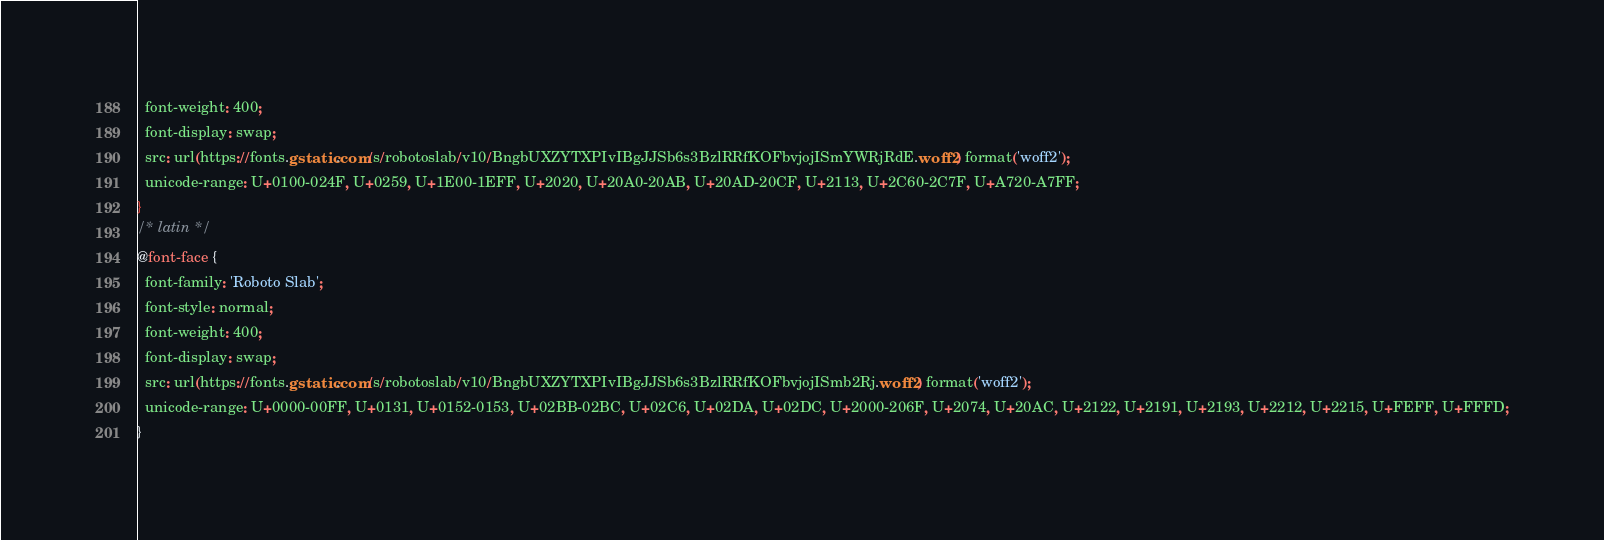Convert code to text. <code><loc_0><loc_0><loc_500><loc_500><_CSS_>  font-weight: 400;
  font-display: swap;
  src: url(https://fonts.gstatic.com/s/robotoslab/v10/BngbUXZYTXPIvIBgJJSb6s3BzlRRfKOFbvjojISmYWRjRdE.woff2) format('woff2');
  unicode-range: U+0100-024F, U+0259, U+1E00-1EFF, U+2020, U+20A0-20AB, U+20AD-20CF, U+2113, U+2C60-2C7F, U+A720-A7FF;
}
/* latin */
@font-face {
  font-family: 'Roboto Slab';
  font-style: normal;
  font-weight: 400;
  font-display: swap;
  src: url(https://fonts.gstatic.com/s/robotoslab/v10/BngbUXZYTXPIvIBgJJSb6s3BzlRRfKOFbvjojISmb2Rj.woff2) format('woff2');
  unicode-range: U+0000-00FF, U+0131, U+0152-0153, U+02BB-02BC, U+02C6, U+02DA, U+02DC, U+2000-206F, U+2074, U+20AC, U+2122, U+2191, U+2193, U+2212, U+2215, U+FEFF, U+FFFD;
}</code> 